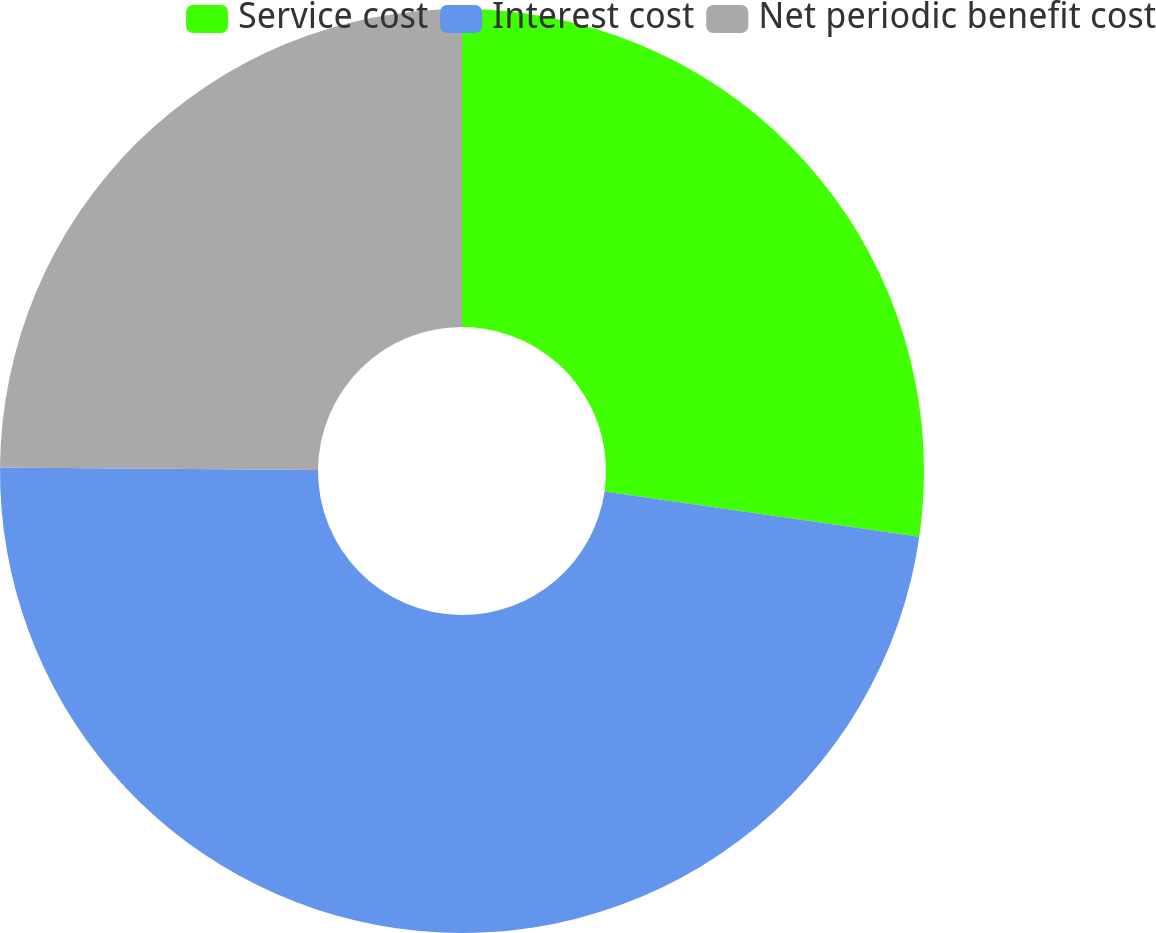Convert chart. <chart><loc_0><loc_0><loc_500><loc_500><pie_chart><fcel>Service cost<fcel>Interest cost<fcel>Net periodic benefit cost<nl><fcel>27.27%<fcel>47.85%<fcel>24.88%<nl></chart> 